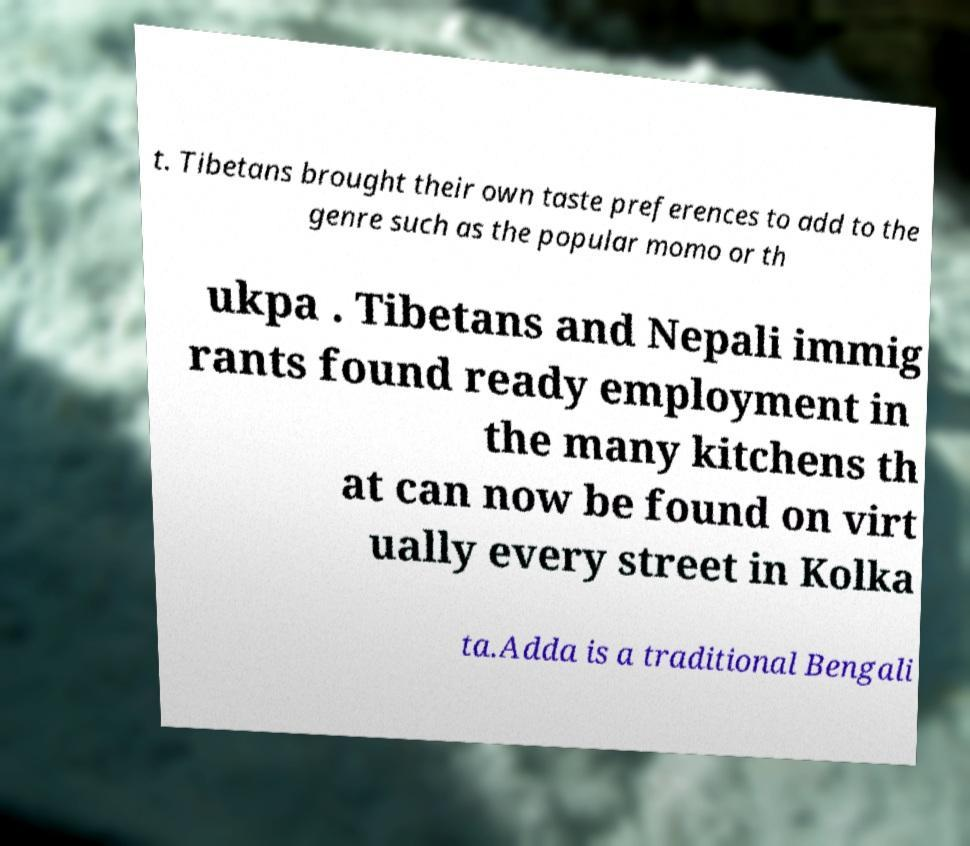What messages or text are displayed in this image? I need them in a readable, typed format. t. Tibetans brought their own taste preferences to add to the genre such as the popular momo or th ukpa . Tibetans and Nepali immig rants found ready employment in the many kitchens th at can now be found on virt ually every street in Kolka ta.Adda is a traditional Bengali 